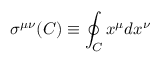Convert formula to latex. <formula><loc_0><loc_0><loc_500><loc_500>\sigma ^ { \mu \nu } ( C ) \equiv \oint _ { C } x ^ { \mu } d x ^ { \nu }</formula> 